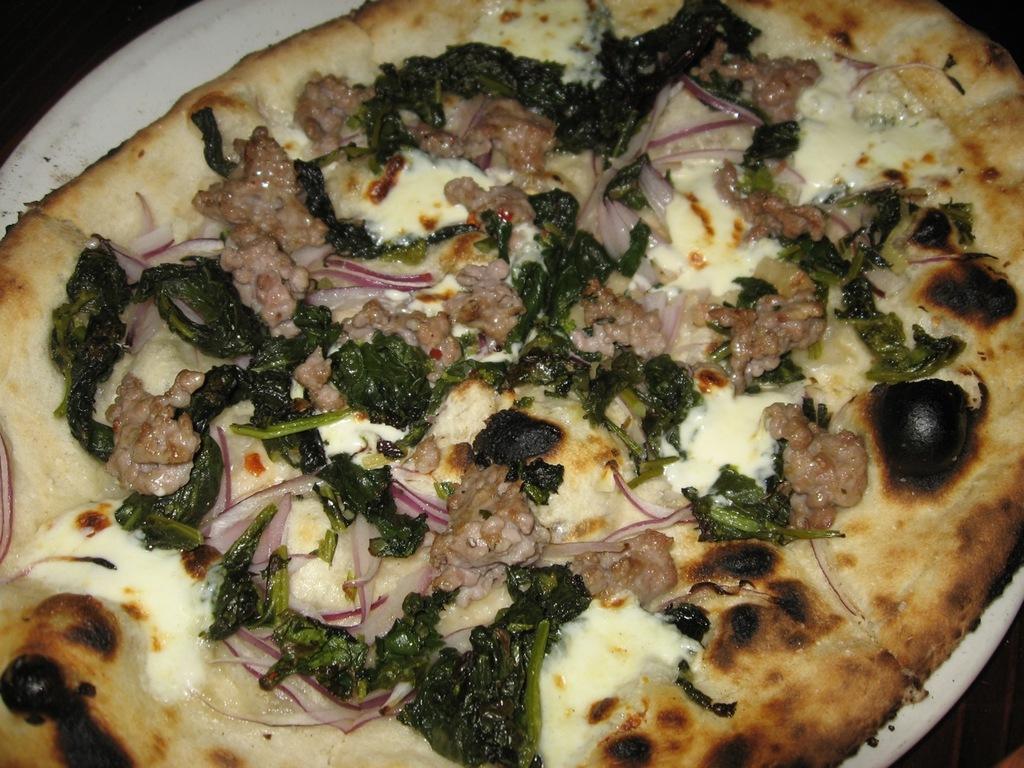Please provide a concise description of this image. In this image, I can see a pizza on a plate. 